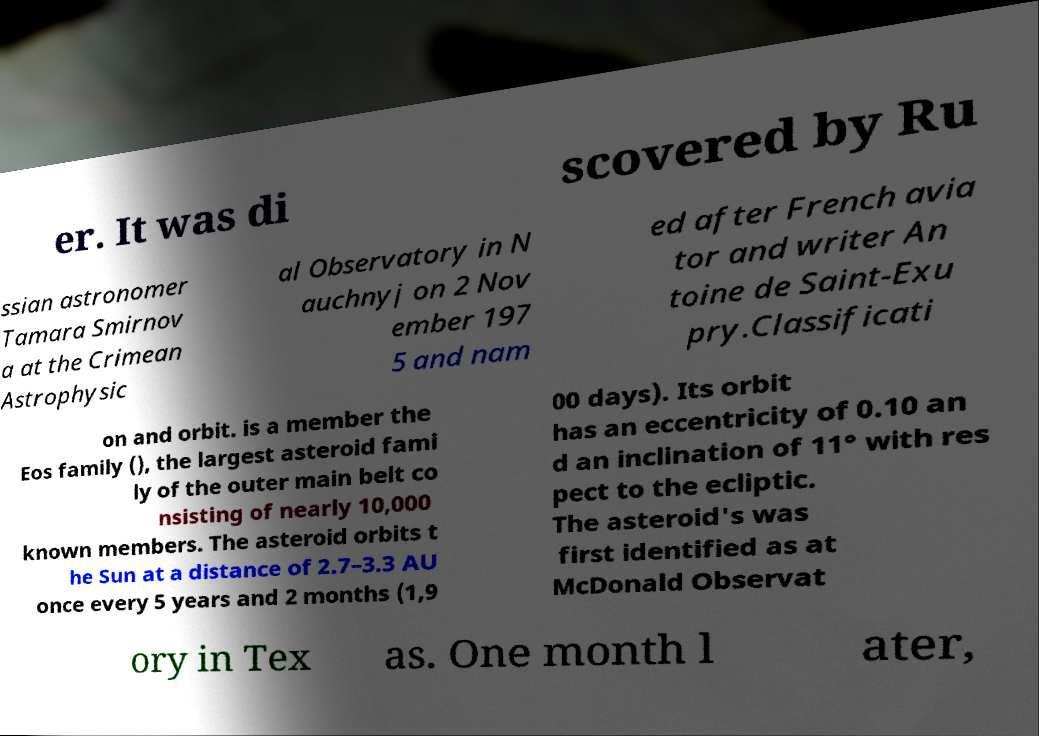Could you extract and type out the text from this image? er. It was di scovered by Ru ssian astronomer Tamara Smirnov a at the Crimean Astrophysic al Observatory in N auchnyj on 2 Nov ember 197 5 and nam ed after French avia tor and writer An toine de Saint-Exu pry.Classificati on and orbit. is a member the Eos family (), the largest asteroid fami ly of the outer main belt co nsisting of nearly 10,000 known members. The asteroid orbits t he Sun at a distance of 2.7–3.3 AU once every 5 years and 2 months (1,9 00 days). Its orbit has an eccentricity of 0.10 an d an inclination of 11° with res pect to the ecliptic. The asteroid's was first identified as at McDonald Observat ory in Tex as. One month l ater, 